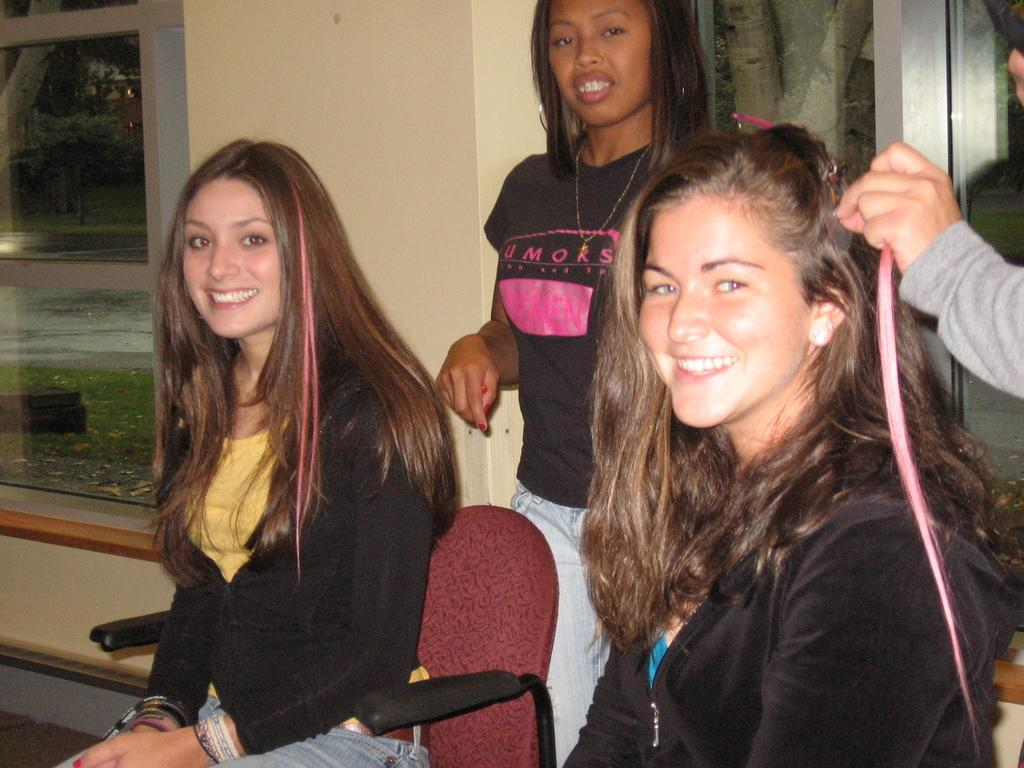How many people are visible in the image? There are four people visible in the image. What are the positions of the people in the image? Two people are sitting on chairs, while two people are standing behind them. What type of skirt is the ant wearing while standing near the drain in the image? There is no ant, skirt, or drain present in the image. 